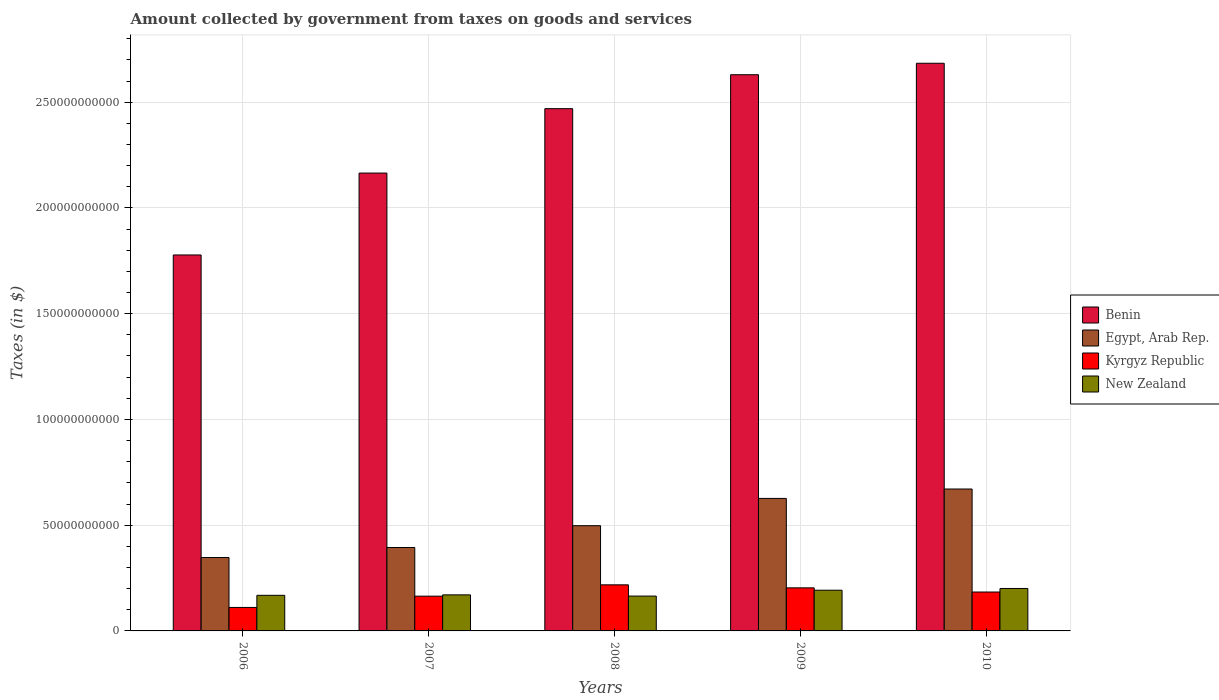How many different coloured bars are there?
Offer a terse response. 4. How many groups of bars are there?
Make the answer very short. 5. Are the number of bars on each tick of the X-axis equal?
Provide a short and direct response. Yes. How many bars are there on the 2nd tick from the right?
Your answer should be very brief. 4. What is the label of the 2nd group of bars from the left?
Provide a short and direct response. 2007. In how many cases, is the number of bars for a given year not equal to the number of legend labels?
Your response must be concise. 0. What is the amount collected by government from taxes on goods and services in Benin in 2006?
Offer a very short reply. 1.78e+11. Across all years, what is the maximum amount collected by government from taxes on goods and services in Egypt, Arab Rep.?
Make the answer very short. 6.71e+1. Across all years, what is the minimum amount collected by government from taxes on goods and services in Benin?
Your answer should be very brief. 1.78e+11. In which year was the amount collected by government from taxes on goods and services in Egypt, Arab Rep. maximum?
Give a very brief answer. 2010. In which year was the amount collected by government from taxes on goods and services in Kyrgyz Republic minimum?
Offer a very short reply. 2006. What is the total amount collected by government from taxes on goods and services in Kyrgyz Republic in the graph?
Offer a terse response. 8.81e+1. What is the difference between the amount collected by government from taxes on goods and services in Kyrgyz Republic in 2006 and that in 2009?
Offer a terse response. -9.27e+09. What is the difference between the amount collected by government from taxes on goods and services in New Zealand in 2008 and the amount collected by government from taxes on goods and services in Egypt, Arab Rep. in 2010?
Offer a very short reply. -5.06e+1. What is the average amount collected by government from taxes on goods and services in New Zealand per year?
Give a very brief answer. 1.79e+1. In the year 2010, what is the difference between the amount collected by government from taxes on goods and services in Egypt, Arab Rep. and amount collected by government from taxes on goods and services in Kyrgyz Republic?
Offer a terse response. 4.87e+1. In how many years, is the amount collected by government from taxes on goods and services in Benin greater than 70000000000 $?
Ensure brevity in your answer.  5. What is the ratio of the amount collected by government from taxes on goods and services in New Zealand in 2007 to that in 2009?
Your response must be concise. 0.89. Is the amount collected by government from taxes on goods and services in Kyrgyz Republic in 2006 less than that in 2010?
Offer a very short reply. Yes. Is the difference between the amount collected by government from taxes on goods and services in Egypt, Arab Rep. in 2007 and 2009 greater than the difference between the amount collected by government from taxes on goods and services in Kyrgyz Republic in 2007 and 2009?
Give a very brief answer. No. What is the difference between the highest and the second highest amount collected by government from taxes on goods and services in Benin?
Provide a succinct answer. 5.42e+09. What is the difference between the highest and the lowest amount collected by government from taxes on goods and services in Egypt, Arab Rep.?
Provide a short and direct response. 3.24e+1. What does the 1st bar from the left in 2009 represents?
Provide a succinct answer. Benin. What does the 3rd bar from the right in 2010 represents?
Your response must be concise. Egypt, Arab Rep. Is it the case that in every year, the sum of the amount collected by government from taxes on goods and services in Benin and amount collected by government from taxes on goods and services in Egypt, Arab Rep. is greater than the amount collected by government from taxes on goods and services in Kyrgyz Republic?
Keep it short and to the point. Yes. Are all the bars in the graph horizontal?
Your answer should be compact. No. How many years are there in the graph?
Ensure brevity in your answer.  5. Are the values on the major ticks of Y-axis written in scientific E-notation?
Keep it short and to the point. No. Does the graph contain any zero values?
Your answer should be very brief. No. Does the graph contain grids?
Your answer should be very brief. Yes. Where does the legend appear in the graph?
Keep it short and to the point. Center right. How are the legend labels stacked?
Your answer should be very brief. Vertical. What is the title of the graph?
Your answer should be compact. Amount collected by government from taxes on goods and services. What is the label or title of the X-axis?
Offer a very short reply. Years. What is the label or title of the Y-axis?
Ensure brevity in your answer.  Taxes (in $). What is the Taxes (in $) in Benin in 2006?
Keep it short and to the point. 1.78e+11. What is the Taxes (in $) in Egypt, Arab Rep. in 2006?
Make the answer very short. 3.47e+1. What is the Taxes (in $) in Kyrgyz Republic in 2006?
Make the answer very short. 1.11e+1. What is the Taxes (in $) of New Zealand in 2006?
Offer a terse response. 1.68e+1. What is the Taxes (in $) in Benin in 2007?
Your answer should be very brief. 2.16e+11. What is the Taxes (in $) of Egypt, Arab Rep. in 2007?
Provide a short and direct response. 3.94e+1. What is the Taxes (in $) in Kyrgyz Republic in 2007?
Your response must be concise. 1.64e+1. What is the Taxes (in $) of New Zealand in 2007?
Keep it short and to the point. 1.70e+1. What is the Taxes (in $) in Benin in 2008?
Your answer should be very brief. 2.47e+11. What is the Taxes (in $) in Egypt, Arab Rep. in 2008?
Keep it short and to the point. 4.97e+1. What is the Taxes (in $) of Kyrgyz Republic in 2008?
Provide a succinct answer. 2.18e+1. What is the Taxes (in $) of New Zealand in 2008?
Your answer should be compact. 1.65e+1. What is the Taxes (in $) of Benin in 2009?
Make the answer very short. 2.63e+11. What is the Taxes (in $) in Egypt, Arab Rep. in 2009?
Ensure brevity in your answer.  6.26e+1. What is the Taxes (in $) of Kyrgyz Republic in 2009?
Your response must be concise. 2.04e+1. What is the Taxes (in $) in New Zealand in 2009?
Provide a succinct answer. 1.92e+1. What is the Taxes (in $) in Benin in 2010?
Make the answer very short. 2.68e+11. What is the Taxes (in $) of Egypt, Arab Rep. in 2010?
Offer a terse response. 6.71e+1. What is the Taxes (in $) in Kyrgyz Republic in 2010?
Your answer should be compact. 1.84e+1. What is the Taxes (in $) in New Zealand in 2010?
Offer a very short reply. 2.01e+1. Across all years, what is the maximum Taxes (in $) of Benin?
Give a very brief answer. 2.68e+11. Across all years, what is the maximum Taxes (in $) in Egypt, Arab Rep.?
Give a very brief answer. 6.71e+1. Across all years, what is the maximum Taxes (in $) in Kyrgyz Republic?
Your answer should be compact. 2.18e+1. Across all years, what is the maximum Taxes (in $) of New Zealand?
Your answer should be very brief. 2.01e+1. Across all years, what is the minimum Taxes (in $) in Benin?
Give a very brief answer. 1.78e+11. Across all years, what is the minimum Taxes (in $) of Egypt, Arab Rep.?
Make the answer very short. 3.47e+1. Across all years, what is the minimum Taxes (in $) of Kyrgyz Republic?
Make the answer very short. 1.11e+1. Across all years, what is the minimum Taxes (in $) of New Zealand?
Offer a very short reply. 1.65e+1. What is the total Taxes (in $) of Benin in the graph?
Keep it short and to the point. 1.17e+12. What is the total Taxes (in $) in Egypt, Arab Rep. in the graph?
Keep it short and to the point. 2.54e+11. What is the total Taxes (in $) of Kyrgyz Republic in the graph?
Offer a very short reply. 8.81e+1. What is the total Taxes (in $) in New Zealand in the graph?
Ensure brevity in your answer.  8.97e+1. What is the difference between the Taxes (in $) in Benin in 2006 and that in 2007?
Make the answer very short. -3.87e+1. What is the difference between the Taxes (in $) in Egypt, Arab Rep. in 2006 and that in 2007?
Keep it short and to the point. -4.74e+09. What is the difference between the Taxes (in $) in Kyrgyz Republic in 2006 and that in 2007?
Provide a short and direct response. -5.34e+09. What is the difference between the Taxes (in $) of New Zealand in 2006 and that in 2007?
Provide a short and direct response. -2.13e+08. What is the difference between the Taxes (in $) in Benin in 2006 and that in 2008?
Keep it short and to the point. -6.92e+1. What is the difference between the Taxes (in $) in Egypt, Arab Rep. in 2006 and that in 2008?
Your response must be concise. -1.50e+1. What is the difference between the Taxes (in $) in Kyrgyz Republic in 2006 and that in 2008?
Your answer should be very brief. -1.07e+1. What is the difference between the Taxes (in $) in New Zealand in 2006 and that in 2008?
Offer a very short reply. 3.59e+08. What is the difference between the Taxes (in $) of Benin in 2006 and that in 2009?
Provide a succinct answer. -8.52e+1. What is the difference between the Taxes (in $) in Egypt, Arab Rep. in 2006 and that in 2009?
Give a very brief answer. -2.80e+1. What is the difference between the Taxes (in $) in Kyrgyz Republic in 2006 and that in 2009?
Make the answer very short. -9.27e+09. What is the difference between the Taxes (in $) of New Zealand in 2006 and that in 2009?
Give a very brief answer. -2.41e+09. What is the difference between the Taxes (in $) of Benin in 2006 and that in 2010?
Give a very brief answer. -9.06e+1. What is the difference between the Taxes (in $) in Egypt, Arab Rep. in 2006 and that in 2010?
Make the answer very short. -3.24e+1. What is the difference between the Taxes (in $) in Kyrgyz Republic in 2006 and that in 2010?
Provide a succinct answer. -7.29e+09. What is the difference between the Taxes (in $) in New Zealand in 2006 and that in 2010?
Give a very brief answer. -3.24e+09. What is the difference between the Taxes (in $) of Benin in 2007 and that in 2008?
Keep it short and to the point. -3.05e+1. What is the difference between the Taxes (in $) in Egypt, Arab Rep. in 2007 and that in 2008?
Your answer should be very brief. -1.03e+1. What is the difference between the Taxes (in $) of Kyrgyz Republic in 2007 and that in 2008?
Your answer should be very brief. -5.35e+09. What is the difference between the Taxes (in $) of New Zealand in 2007 and that in 2008?
Provide a succinct answer. 5.72e+08. What is the difference between the Taxes (in $) in Benin in 2007 and that in 2009?
Your response must be concise. -4.65e+1. What is the difference between the Taxes (in $) of Egypt, Arab Rep. in 2007 and that in 2009?
Give a very brief answer. -2.32e+1. What is the difference between the Taxes (in $) in Kyrgyz Republic in 2007 and that in 2009?
Give a very brief answer. -3.93e+09. What is the difference between the Taxes (in $) in New Zealand in 2007 and that in 2009?
Give a very brief answer. -2.20e+09. What is the difference between the Taxes (in $) in Benin in 2007 and that in 2010?
Give a very brief answer. -5.19e+1. What is the difference between the Taxes (in $) in Egypt, Arab Rep. in 2007 and that in 2010?
Give a very brief answer. -2.77e+1. What is the difference between the Taxes (in $) of Kyrgyz Republic in 2007 and that in 2010?
Your answer should be compact. -1.95e+09. What is the difference between the Taxes (in $) in New Zealand in 2007 and that in 2010?
Provide a succinct answer. -3.02e+09. What is the difference between the Taxes (in $) in Benin in 2008 and that in 2009?
Offer a terse response. -1.60e+1. What is the difference between the Taxes (in $) in Egypt, Arab Rep. in 2008 and that in 2009?
Your answer should be compact. -1.29e+1. What is the difference between the Taxes (in $) of Kyrgyz Republic in 2008 and that in 2009?
Provide a succinct answer. 1.42e+09. What is the difference between the Taxes (in $) in New Zealand in 2008 and that in 2009?
Provide a succinct answer. -2.77e+09. What is the difference between the Taxes (in $) in Benin in 2008 and that in 2010?
Your response must be concise. -2.15e+1. What is the difference between the Taxes (in $) of Egypt, Arab Rep. in 2008 and that in 2010?
Your answer should be very brief. -1.73e+1. What is the difference between the Taxes (in $) in Kyrgyz Republic in 2008 and that in 2010?
Your answer should be very brief. 3.40e+09. What is the difference between the Taxes (in $) in New Zealand in 2008 and that in 2010?
Ensure brevity in your answer.  -3.60e+09. What is the difference between the Taxes (in $) in Benin in 2009 and that in 2010?
Your answer should be compact. -5.42e+09. What is the difference between the Taxes (in $) in Egypt, Arab Rep. in 2009 and that in 2010?
Offer a very short reply. -4.44e+09. What is the difference between the Taxes (in $) in Kyrgyz Republic in 2009 and that in 2010?
Give a very brief answer. 1.98e+09. What is the difference between the Taxes (in $) in New Zealand in 2009 and that in 2010?
Make the answer very short. -8.25e+08. What is the difference between the Taxes (in $) of Benin in 2006 and the Taxes (in $) of Egypt, Arab Rep. in 2007?
Provide a succinct answer. 1.38e+11. What is the difference between the Taxes (in $) in Benin in 2006 and the Taxes (in $) in Kyrgyz Republic in 2007?
Provide a succinct answer. 1.61e+11. What is the difference between the Taxes (in $) of Benin in 2006 and the Taxes (in $) of New Zealand in 2007?
Keep it short and to the point. 1.61e+11. What is the difference between the Taxes (in $) in Egypt, Arab Rep. in 2006 and the Taxes (in $) in Kyrgyz Republic in 2007?
Your response must be concise. 1.83e+1. What is the difference between the Taxes (in $) in Egypt, Arab Rep. in 2006 and the Taxes (in $) in New Zealand in 2007?
Ensure brevity in your answer.  1.77e+1. What is the difference between the Taxes (in $) of Kyrgyz Republic in 2006 and the Taxes (in $) of New Zealand in 2007?
Your answer should be very brief. -5.95e+09. What is the difference between the Taxes (in $) in Benin in 2006 and the Taxes (in $) in Egypt, Arab Rep. in 2008?
Offer a very short reply. 1.28e+11. What is the difference between the Taxes (in $) of Benin in 2006 and the Taxes (in $) of Kyrgyz Republic in 2008?
Your answer should be compact. 1.56e+11. What is the difference between the Taxes (in $) of Benin in 2006 and the Taxes (in $) of New Zealand in 2008?
Provide a short and direct response. 1.61e+11. What is the difference between the Taxes (in $) of Egypt, Arab Rep. in 2006 and the Taxes (in $) of Kyrgyz Republic in 2008?
Keep it short and to the point. 1.29e+1. What is the difference between the Taxes (in $) of Egypt, Arab Rep. in 2006 and the Taxes (in $) of New Zealand in 2008?
Keep it short and to the point. 1.82e+1. What is the difference between the Taxes (in $) of Kyrgyz Republic in 2006 and the Taxes (in $) of New Zealand in 2008?
Your response must be concise. -5.38e+09. What is the difference between the Taxes (in $) of Benin in 2006 and the Taxes (in $) of Egypt, Arab Rep. in 2009?
Provide a short and direct response. 1.15e+11. What is the difference between the Taxes (in $) in Benin in 2006 and the Taxes (in $) in Kyrgyz Republic in 2009?
Provide a short and direct response. 1.57e+11. What is the difference between the Taxes (in $) of Benin in 2006 and the Taxes (in $) of New Zealand in 2009?
Give a very brief answer. 1.59e+11. What is the difference between the Taxes (in $) of Egypt, Arab Rep. in 2006 and the Taxes (in $) of Kyrgyz Republic in 2009?
Offer a very short reply. 1.43e+1. What is the difference between the Taxes (in $) in Egypt, Arab Rep. in 2006 and the Taxes (in $) in New Zealand in 2009?
Ensure brevity in your answer.  1.55e+1. What is the difference between the Taxes (in $) of Kyrgyz Republic in 2006 and the Taxes (in $) of New Zealand in 2009?
Keep it short and to the point. -8.15e+09. What is the difference between the Taxes (in $) in Benin in 2006 and the Taxes (in $) in Egypt, Arab Rep. in 2010?
Your response must be concise. 1.11e+11. What is the difference between the Taxes (in $) in Benin in 2006 and the Taxes (in $) in Kyrgyz Republic in 2010?
Offer a very short reply. 1.59e+11. What is the difference between the Taxes (in $) in Benin in 2006 and the Taxes (in $) in New Zealand in 2010?
Make the answer very short. 1.58e+11. What is the difference between the Taxes (in $) in Egypt, Arab Rep. in 2006 and the Taxes (in $) in Kyrgyz Republic in 2010?
Ensure brevity in your answer.  1.63e+1. What is the difference between the Taxes (in $) of Egypt, Arab Rep. in 2006 and the Taxes (in $) of New Zealand in 2010?
Your answer should be compact. 1.46e+1. What is the difference between the Taxes (in $) in Kyrgyz Republic in 2006 and the Taxes (in $) in New Zealand in 2010?
Give a very brief answer. -8.97e+09. What is the difference between the Taxes (in $) in Benin in 2007 and the Taxes (in $) in Egypt, Arab Rep. in 2008?
Your response must be concise. 1.67e+11. What is the difference between the Taxes (in $) in Benin in 2007 and the Taxes (in $) in Kyrgyz Republic in 2008?
Your answer should be very brief. 1.95e+11. What is the difference between the Taxes (in $) in Benin in 2007 and the Taxes (in $) in New Zealand in 2008?
Give a very brief answer. 2.00e+11. What is the difference between the Taxes (in $) of Egypt, Arab Rep. in 2007 and the Taxes (in $) of Kyrgyz Republic in 2008?
Give a very brief answer. 1.76e+1. What is the difference between the Taxes (in $) of Egypt, Arab Rep. in 2007 and the Taxes (in $) of New Zealand in 2008?
Your answer should be compact. 2.30e+1. What is the difference between the Taxes (in $) in Kyrgyz Republic in 2007 and the Taxes (in $) in New Zealand in 2008?
Give a very brief answer. -3.92e+07. What is the difference between the Taxes (in $) of Benin in 2007 and the Taxes (in $) of Egypt, Arab Rep. in 2009?
Keep it short and to the point. 1.54e+11. What is the difference between the Taxes (in $) of Benin in 2007 and the Taxes (in $) of Kyrgyz Republic in 2009?
Provide a succinct answer. 1.96e+11. What is the difference between the Taxes (in $) in Benin in 2007 and the Taxes (in $) in New Zealand in 2009?
Offer a terse response. 1.97e+11. What is the difference between the Taxes (in $) of Egypt, Arab Rep. in 2007 and the Taxes (in $) of Kyrgyz Republic in 2009?
Give a very brief answer. 1.91e+1. What is the difference between the Taxes (in $) of Egypt, Arab Rep. in 2007 and the Taxes (in $) of New Zealand in 2009?
Your answer should be very brief. 2.02e+1. What is the difference between the Taxes (in $) in Kyrgyz Republic in 2007 and the Taxes (in $) in New Zealand in 2009?
Your answer should be very brief. -2.81e+09. What is the difference between the Taxes (in $) in Benin in 2007 and the Taxes (in $) in Egypt, Arab Rep. in 2010?
Provide a succinct answer. 1.49e+11. What is the difference between the Taxes (in $) in Benin in 2007 and the Taxes (in $) in Kyrgyz Republic in 2010?
Your answer should be compact. 1.98e+11. What is the difference between the Taxes (in $) in Benin in 2007 and the Taxes (in $) in New Zealand in 2010?
Provide a succinct answer. 1.96e+11. What is the difference between the Taxes (in $) in Egypt, Arab Rep. in 2007 and the Taxes (in $) in Kyrgyz Republic in 2010?
Ensure brevity in your answer.  2.10e+1. What is the difference between the Taxes (in $) of Egypt, Arab Rep. in 2007 and the Taxes (in $) of New Zealand in 2010?
Offer a terse response. 1.94e+1. What is the difference between the Taxes (in $) in Kyrgyz Republic in 2007 and the Taxes (in $) in New Zealand in 2010?
Provide a succinct answer. -3.63e+09. What is the difference between the Taxes (in $) of Benin in 2008 and the Taxes (in $) of Egypt, Arab Rep. in 2009?
Give a very brief answer. 1.84e+11. What is the difference between the Taxes (in $) of Benin in 2008 and the Taxes (in $) of Kyrgyz Republic in 2009?
Provide a succinct answer. 2.27e+11. What is the difference between the Taxes (in $) of Benin in 2008 and the Taxes (in $) of New Zealand in 2009?
Keep it short and to the point. 2.28e+11. What is the difference between the Taxes (in $) of Egypt, Arab Rep. in 2008 and the Taxes (in $) of Kyrgyz Republic in 2009?
Keep it short and to the point. 2.94e+1. What is the difference between the Taxes (in $) in Egypt, Arab Rep. in 2008 and the Taxes (in $) in New Zealand in 2009?
Offer a terse response. 3.05e+1. What is the difference between the Taxes (in $) of Kyrgyz Republic in 2008 and the Taxes (in $) of New Zealand in 2009?
Provide a succinct answer. 2.54e+09. What is the difference between the Taxes (in $) of Benin in 2008 and the Taxes (in $) of Egypt, Arab Rep. in 2010?
Ensure brevity in your answer.  1.80e+11. What is the difference between the Taxes (in $) in Benin in 2008 and the Taxes (in $) in Kyrgyz Republic in 2010?
Provide a succinct answer. 2.29e+11. What is the difference between the Taxes (in $) of Benin in 2008 and the Taxes (in $) of New Zealand in 2010?
Offer a terse response. 2.27e+11. What is the difference between the Taxes (in $) of Egypt, Arab Rep. in 2008 and the Taxes (in $) of Kyrgyz Republic in 2010?
Offer a very short reply. 3.14e+1. What is the difference between the Taxes (in $) of Egypt, Arab Rep. in 2008 and the Taxes (in $) of New Zealand in 2010?
Your answer should be very brief. 2.97e+1. What is the difference between the Taxes (in $) of Kyrgyz Republic in 2008 and the Taxes (in $) of New Zealand in 2010?
Your answer should be very brief. 1.72e+09. What is the difference between the Taxes (in $) in Benin in 2009 and the Taxes (in $) in Egypt, Arab Rep. in 2010?
Offer a terse response. 1.96e+11. What is the difference between the Taxes (in $) in Benin in 2009 and the Taxes (in $) in Kyrgyz Republic in 2010?
Make the answer very short. 2.45e+11. What is the difference between the Taxes (in $) in Benin in 2009 and the Taxes (in $) in New Zealand in 2010?
Your answer should be compact. 2.43e+11. What is the difference between the Taxes (in $) in Egypt, Arab Rep. in 2009 and the Taxes (in $) in Kyrgyz Republic in 2010?
Make the answer very short. 4.43e+1. What is the difference between the Taxes (in $) in Egypt, Arab Rep. in 2009 and the Taxes (in $) in New Zealand in 2010?
Ensure brevity in your answer.  4.26e+1. What is the difference between the Taxes (in $) of Kyrgyz Republic in 2009 and the Taxes (in $) of New Zealand in 2010?
Ensure brevity in your answer.  2.95e+08. What is the average Taxes (in $) in Benin per year?
Provide a short and direct response. 2.35e+11. What is the average Taxes (in $) of Egypt, Arab Rep. per year?
Ensure brevity in your answer.  5.07e+1. What is the average Taxes (in $) in Kyrgyz Republic per year?
Provide a succinct answer. 1.76e+1. What is the average Taxes (in $) in New Zealand per year?
Provide a short and direct response. 1.79e+1. In the year 2006, what is the difference between the Taxes (in $) in Benin and Taxes (in $) in Egypt, Arab Rep.?
Provide a short and direct response. 1.43e+11. In the year 2006, what is the difference between the Taxes (in $) of Benin and Taxes (in $) of Kyrgyz Republic?
Provide a short and direct response. 1.67e+11. In the year 2006, what is the difference between the Taxes (in $) in Benin and Taxes (in $) in New Zealand?
Give a very brief answer. 1.61e+11. In the year 2006, what is the difference between the Taxes (in $) in Egypt, Arab Rep. and Taxes (in $) in Kyrgyz Republic?
Provide a short and direct response. 2.36e+1. In the year 2006, what is the difference between the Taxes (in $) in Egypt, Arab Rep. and Taxes (in $) in New Zealand?
Provide a succinct answer. 1.79e+1. In the year 2006, what is the difference between the Taxes (in $) of Kyrgyz Republic and Taxes (in $) of New Zealand?
Offer a very short reply. -5.73e+09. In the year 2007, what is the difference between the Taxes (in $) of Benin and Taxes (in $) of Egypt, Arab Rep.?
Offer a very short reply. 1.77e+11. In the year 2007, what is the difference between the Taxes (in $) of Benin and Taxes (in $) of Kyrgyz Republic?
Provide a succinct answer. 2.00e+11. In the year 2007, what is the difference between the Taxes (in $) of Benin and Taxes (in $) of New Zealand?
Offer a terse response. 1.99e+11. In the year 2007, what is the difference between the Taxes (in $) of Egypt, Arab Rep. and Taxes (in $) of Kyrgyz Republic?
Offer a very short reply. 2.30e+1. In the year 2007, what is the difference between the Taxes (in $) in Egypt, Arab Rep. and Taxes (in $) in New Zealand?
Offer a very short reply. 2.24e+1. In the year 2007, what is the difference between the Taxes (in $) in Kyrgyz Republic and Taxes (in $) in New Zealand?
Ensure brevity in your answer.  -6.12e+08. In the year 2008, what is the difference between the Taxes (in $) of Benin and Taxes (in $) of Egypt, Arab Rep.?
Give a very brief answer. 1.97e+11. In the year 2008, what is the difference between the Taxes (in $) in Benin and Taxes (in $) in Kyrgyz Republic?
Offer a very short reply. 2.25e+11. In the year 2008, what is the difference between the Taxes (in $) in Benin and Taxes (in $) in New Zealand?
Ensure brevity in your answer.  2.30e+11. In the year 2008, what is the difference between the Taxes (in $) in Egypt, Arab Rep. and Taxes (in $) in Kyrgyz Republic?
Your answer should be compact. 2.80e+1. In the year 2008, what is the difference between the Taxes (in $) of Egypt, Arab Rep. and Taxes (in $) of New Zealand?
Ensure brevity in your answer.  3.33e+1. In the year 2008, what is the difference between the Taxes (in $) in Kyrgyz Republic and Taxes (in $) in New Zealand?
Provide a short and direct response. 5.31e+09. In the year 2009, what is the difference between the Taxes (in $) of Benin and Taxes (in $) of Egypt, Arab Rep.?
Ensure brevity in your answer.  2.00e+11. In the year 2009, what is the difference between the Taxes (in $) in Benin and Taxes (in $) in Kyrgyz Republic?
Ensure brevity in your answer.  2.43e+11. In the year 2009, what is the difference between the Taxes (in $) of Benin and Taxes (in $) of New Zealand?
Your response must be concise. 2.44e+11. In the year 2009, what is the difference between the Taxes (in $) of Egypt, Arab Rep. and Taxes (in $) of Kyrgyz Republic?
Offer a very short reply. 4.23e+1. In the year 2009, what is the difference between the Taxes (in $) of Egypt, Arab Rep. and Taxes (in $) of New Zealand?
Ensure brevity in your answer.  4.34e+1. In the year 2009, what is the difference between the Taxes (in $) in Kyrgyz Republic and Taxes (in $) in New Zealand?
Make the answer very short. 1.12e+09. In the year 2010, what is the difference between the Taxes (in $) in Benin and Taxes (in $) in Egypt, Arab Rep.?
Offer a very short reply. 2.01e+11. In the year 2010, what is the difference between the Taxes (in $) in Benin and Taxes (in $) in Kyrgyz Republic?
Make the answer very short. 2.50e+11. In the year 2010, what is the difference between the Taxes (in $) of Benin and Taxes (in $) of New Zealand?
Offer a very short reply. 2.48e+11. In the year 2010, what is the difference between the Taxes (in $) in Egypt, Arab Rep. and Taxes (in $) in Kyrgyz Republic?
Ensure brevity in your answer.  4.87e+1. In the year 2010, what is the difference between the Taxes (in $) of Egypt, Arab Rep. and Taxes (in $) of New Zealand?
Keep it short and to the point. 4.70e+1. In the year 2010, what is the difference between the Taxes (in $) of Kyrgyz Republic and Taxes (in $) of New Zealand?
Offer a very short reply. -1.68e+09. What is the ratio of the Taxes (in $) of Benin in 2006 to that in 2007?
Keep it short and to the point. 0.82. What is the ratio of the Taxes (in $) of Egypt, Arab Rep. in 2006 to that in 2007?
Offer a terse response. 0.88. What is the ratio of the Taxes (in $) of Kyrgyz Republic in 2006 to that in 2007?
Provide a succinct answer. 0.68. What is the ratio of the Taxes (in $) of New Zealand in 2006 to that in 2007?
Your answer should be compact. 0.99. What is the ratio of the Taxes (in $) in Benin in 2006 to that in 2008?
Your answer should be very brief. 0.72. What is the ratio of the Taxes (in $) of Egypt, Arab Rep. in 2006 to that in 2008?
Your answer should be compact. 0.7. What is the ratio of the Taxes (in $) in Kyrgyz Republic in 2006 to that in 2008?
Ensure brevity in your answer.  0.51. What is the ratio of the Taxes (in $) of New Zealand in 2006 to that in 2008?
Make the answer very short. 1.02. What is the ratio of the Taxes (in $) of Benin in 2006 to that in 2009?
Your answer should be compact. 0.68. What is the ratio of the Taxes (in $) of Egypt, Arab Rep. in 2006 to that in 2009?
Keep it short and to the point. 0.55. What is the ratio of the Taxes (in $) of Kyrgyz Republic in 2006 to that in 2009?
Your answer should be compact. 0.55. What is the ratio of the Taxes (in $) in New Zealand in 2006 to that in 2009?
Offer a very short reply. 0.87. What is the ratio of the Taxes (in $) in Benin in 2006 to that in 2010?
Keep it short and to the point. 0.66. What is the ratio of the Taxes (in $) in Egypt, Arab Rep. in 2006 to that in 2010?
Offer a very short reply. 0.52. What is the ratio of the Taxes (in $) of Kyrgyz Republic in 2006 to that in 2010?
Your response must be concise. 0.6. What is the ratio of the Taxes (in $) in New Zealand in 2006 to that in 2010?
Your response must be concise. 0.84. What is the ratio of the Taxes (in $) of Benin in 2007 to that in 2008?
Ensure brevity in your answer.  0.88. What is the ratio of the Taxes (in $) of Egypt, Arab Rep. in 2007 to that in 2008?
Ensure brevity in your answer.  0.79. What is the ratio of the Taxes (in $) of Kyrgyz Republic in 2007 to that in 2008?
Your answer should be very brief. 0.75. What is the ratio of the Taxes (in $) in New Zealand in 2007 to that in 2008?
Provide a succinct answer. 1.03. What is the ratio of the Taxes (in $) of Benin in 2007 to that in 2009?
Provide a short and direct response. 0.82. What is the ratio of the Taxes (in $) of Egypt, Arab Rep. in 2007 to that in 2009?
Provide a short and direct response. 0.63. What is the ratio of the Taxes (in $) of Kyrgyz Republic in 2007 to that in 2009?
Provide a short and direct response. 0.81. What is the ratio of the Taxes (in $) of New Zealand in 2007 to that in 2009?
Offer a very short reply. 0.89. What is the ratio of the Taxes (in $) of Benin in 2007 to that in 2010?
Make the answer very short. 0.81. What is the ratio of the Taxes (in $) in Egypt, Arab Rep. in 2007 to that in 2010?
Make the answer very short. 0.59. What is the ratio of the Taxes (in $) in Kyrgyz Republic in 2007 to that in 2010?
Provide a short and direct response. 0.89. What is the ratio of the Taxes (in $) in New Zealand in 2007 to that in 2010?
Provide a succinct answer. 0.85. What is the ratio of the Taxes (in $) of Benin in 2008 to that in 2009?
Ensure brevity in your answer.  0.94. What is the ratio of the Taxes (in $) of Egypt, Arab Rep. in 2008 to that in 2009?
Your answer should be compact. 0.79. What is the ratio of the Taxes (in $) in Kyrgyz Republic in 2008 to that in 2009?
Offer a very short reply. 1.07. What is the ratio of the Taxes (in $) in New Zealand in 2008 to that in 2009?
Offer a very short reply. 0.86. What is the ratio of the Taxes (in $) of Egypt, Arab Rep. in 2008 to that in 2010?
Offer a very short reply. 0.74. What is the ratio of the Taxes (in $) of Kyrgyz Republic in 2008 to that in 2010?
Provide a short and direct response. 1.18. What is the ratio of the Taxes (in $) of New Zealand in 2008 to that in 2010?
Your answer should be compact. 0.82. What is the ratio of the Taxes (in $) of Benin in 2009 to that in 2010?
Your answer should be very brief. 0.98. What is the ratio of the Taxes (in $) in Egypt, Arab Rep. in 2009 to that in 2010?
Provide a succinct answer. 0.93. What is the ratio of the Taxes (in $) of Kyrgyz Republic in 2009 to that in 2010?
Provide a succinct answer. 1.11. What is the ratio of the Taxes (in $) in New Zealand in 2009 to that in 2010?
Your answer should be very brief. 0.96. What is the difference between the highest and the second highest Taxes (in $) in Benin?
Provide a succinct answer. 5.42e+09. What is the difference between the highest and the second highest Taxes (in $) of Egypt, Arab Rep.?
Keep it short and to the point. 4.44e+09. What is the difference between the highest and the second highest Taxes (in $) in Kyrgyz Republic?
Keep it short and to the point. 1.42e+09. What is the difference between the highest and the second highest Taxes (in $) in New Zealand?
Offer a very short reply. 8.25e+08. What is the difference between the highest and the lowest Taxes (in $) in Benin?
Keep it short and to the point. 9.06e+1. What is the difference between the highest and the lowest Taxes (in $) in Egypt, Arab Rep.?
Your response must be concise. 3.24e+1. What is the difference between the highest and the lowest Taxes (in $) of Kyrgyz Republic?
Your response must be concise. 1.07e+1. What is the difference between the highest and the lowest Taxes (in $) of New Zealand?
Ensure brevity in your answer.  3.60e+09. 